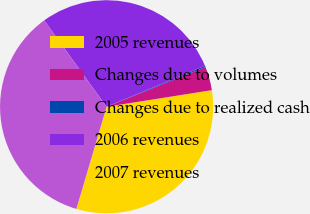<chart> <loc_0><loc_0><loc_500><loc_500><pie_chart><fcel>2005 revenues<fcel>Changes due to volumes<fcel>Changes due to realized cash<fcel>2006 revenues<fcel>2007 revenues<nl><fcel>32.07%<fcel>3.59%<fcel>0.2%<fcel>28.68%<fcel>35.46%<nl></chart> 